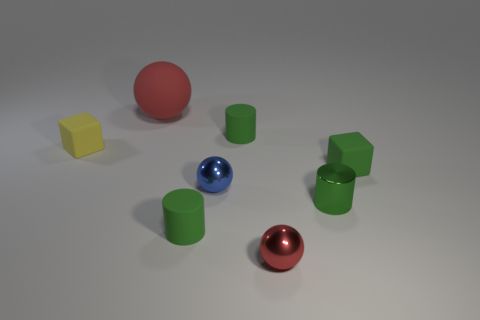There is a green matte object that is behind the object that is left of the big red rubber object; what shape is it? The green matte object positioned behind the object to the left of the large red sphere is a cylinder. Its surface is matte, in contrast to the shiny textures of some other items in the scene, and its cylindrical shape can be discerned from its circular base and elongated body. 